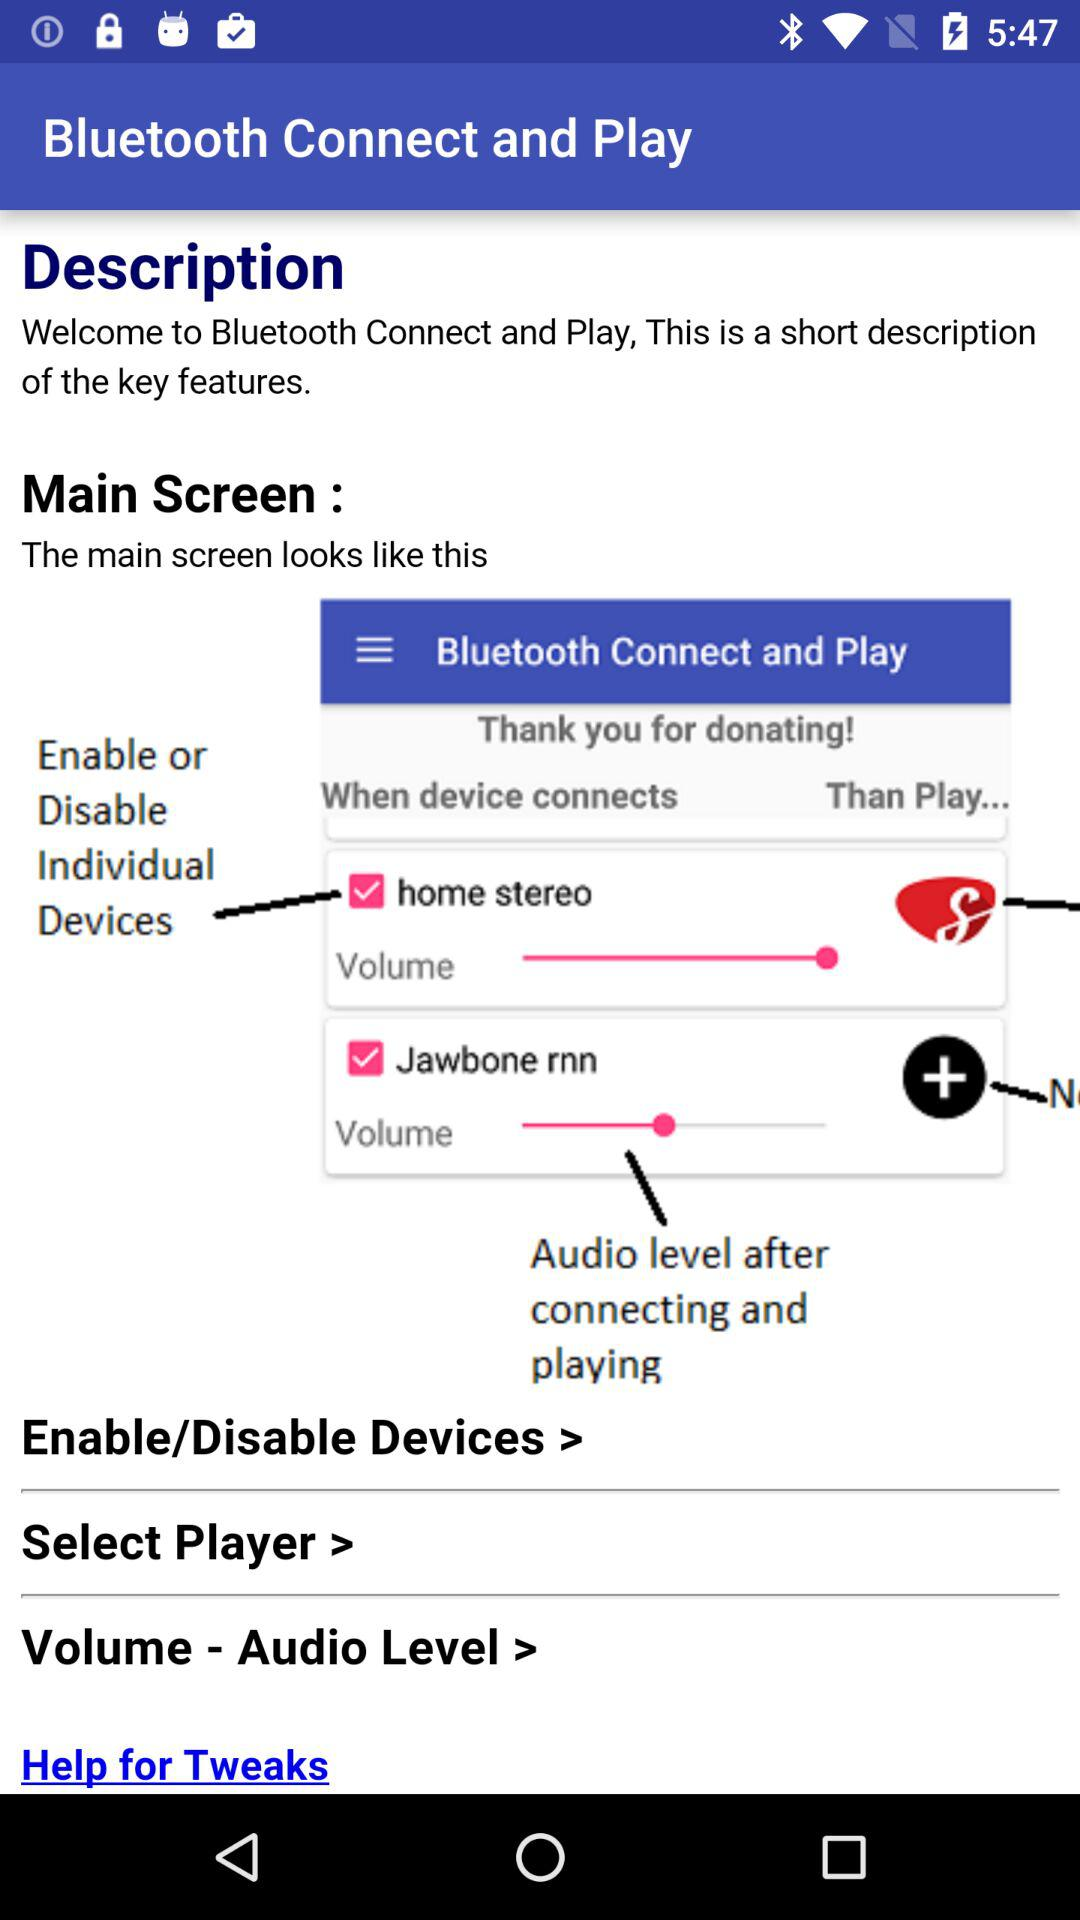How many devices are connected?
Answer the question using a single word or phrase. 2 